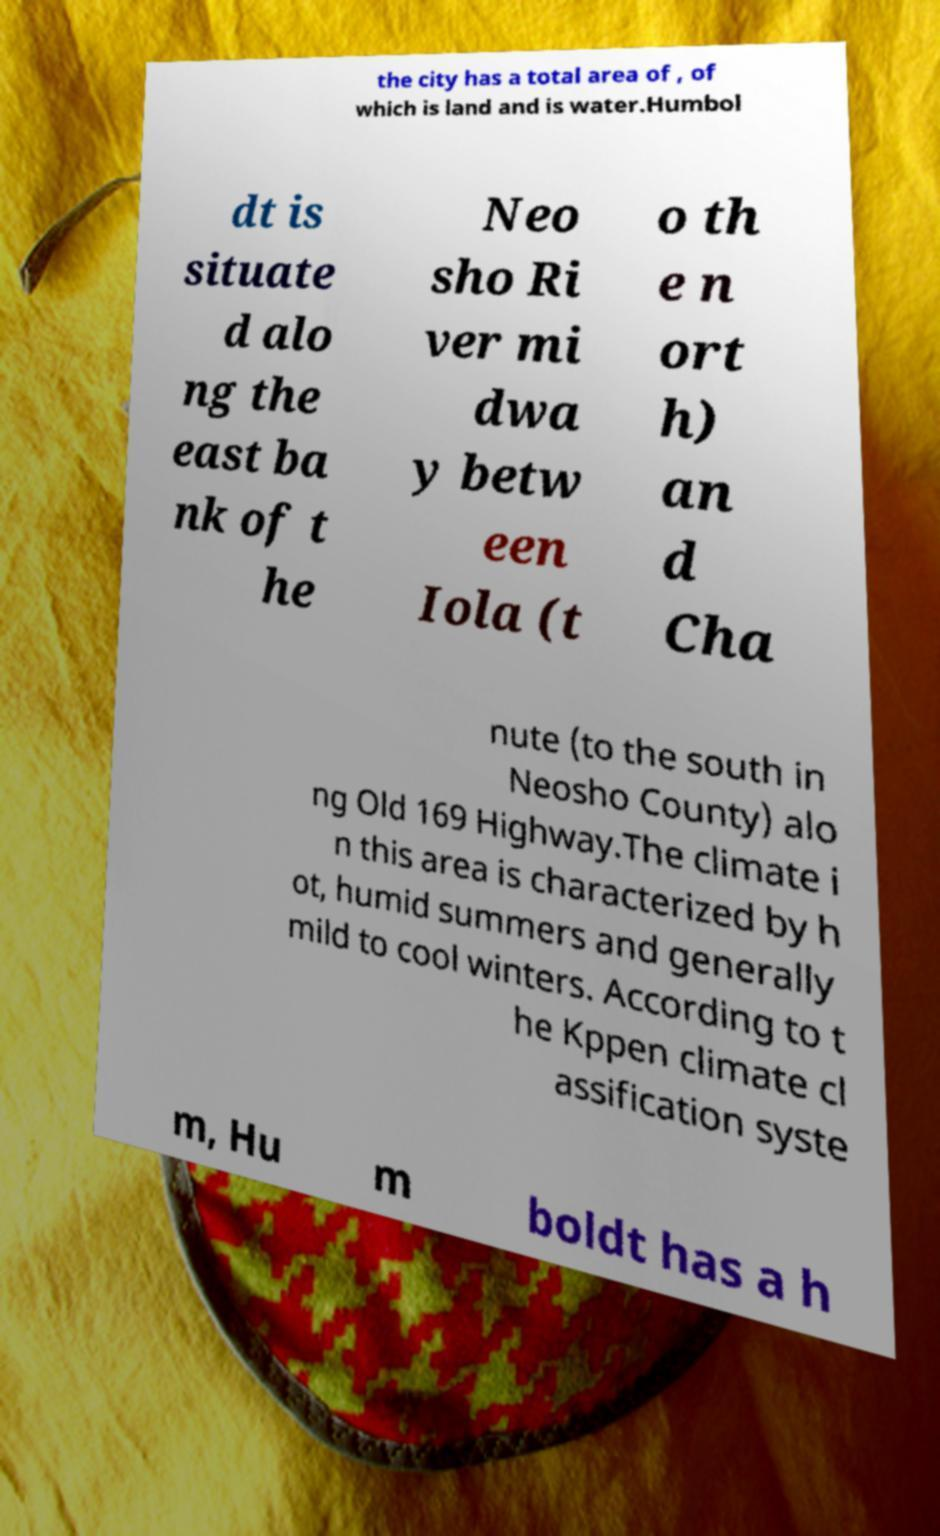Please identify and transcribe the text found in this image. the city has a total area of , of which is land and is water.Humbol dt is situate d alo ng the east ba nk of t he Neo sho Ri ver mi dwa y betw een Iola (t o th e n ort h) an d Cha nute (to the south in Neosho County) alo ng Old 169 Highway.The climate i n this area is characterized by h ot, humid summers and generally mild to cool winters. According to t he Kppen climate cl assification syste m, Hu m boldt has a h 